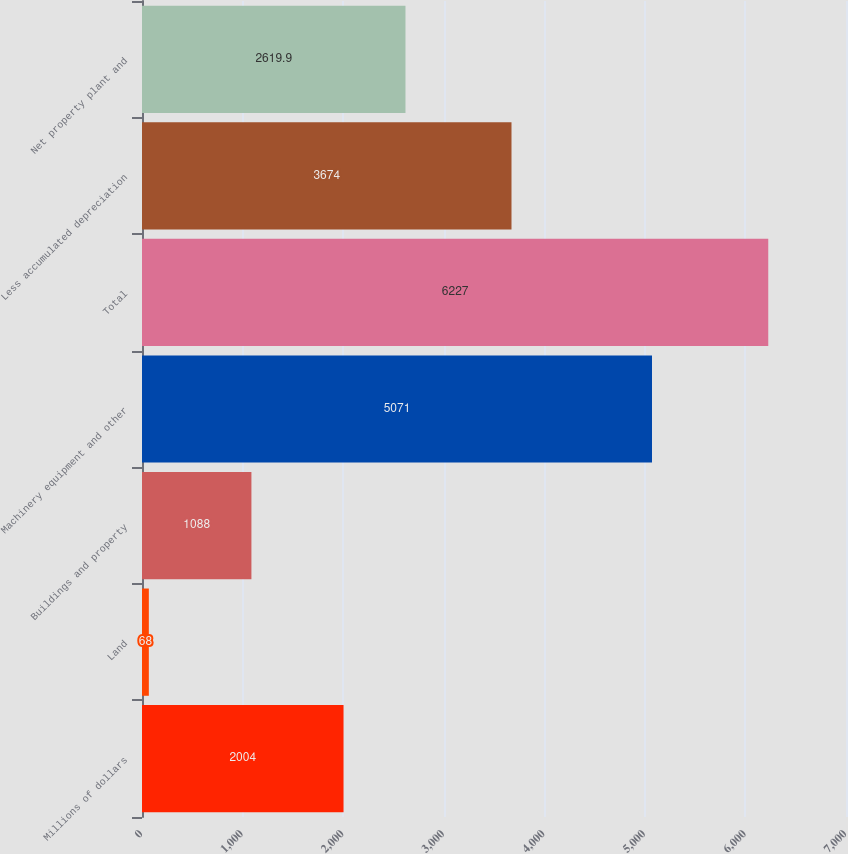Convert chart to OTSL. <chart><loc_0><loc_0><loc_500><loc_500><bar_chart><fcel>Millions of dollars<fcel>Land<fcel>Buildings and property<fcel>Machinery equipment and other<fcel>Total<fcel>Less accumulated depreciation<fcel>Net property plant and<nl><fcel>2004<fcel>68<fcel>1088<fcel>5071<fcel>6227<fcel>3674<fcel>2619.9<nl></chart> 